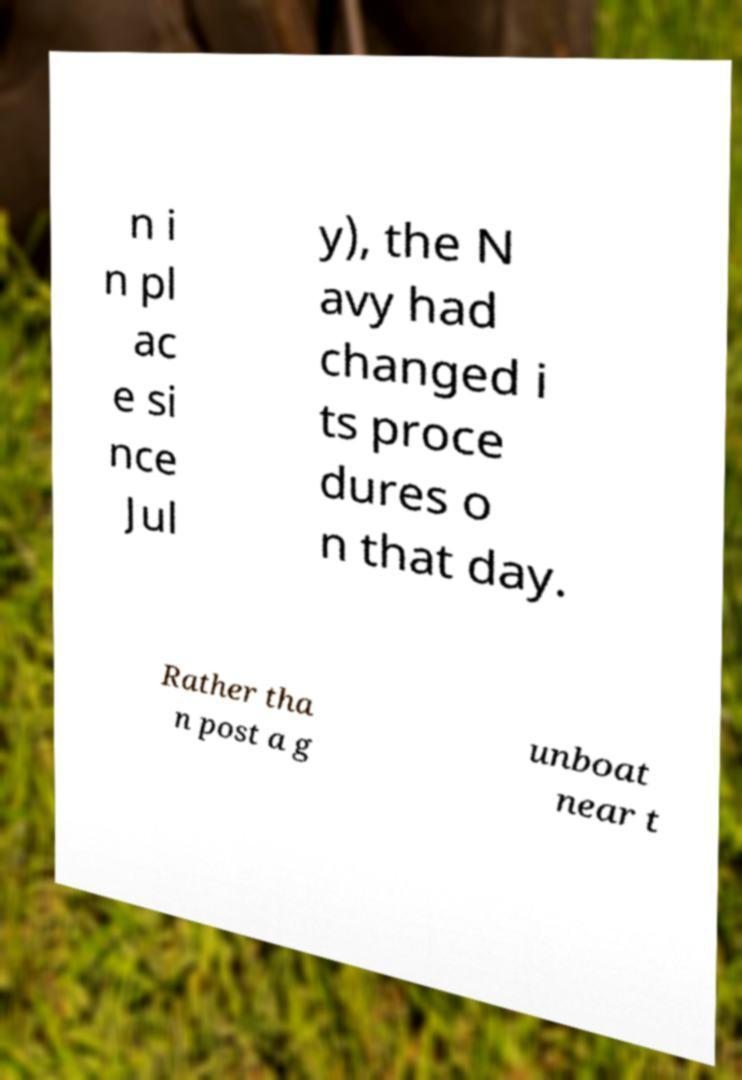For documentation purposes, I need the text within this image transcribed. Could you provide that? n i n pl ac e si nce Jul y), the N avy had changed i ts proce dures o n that day. Rather tha n post a g unboat near t 